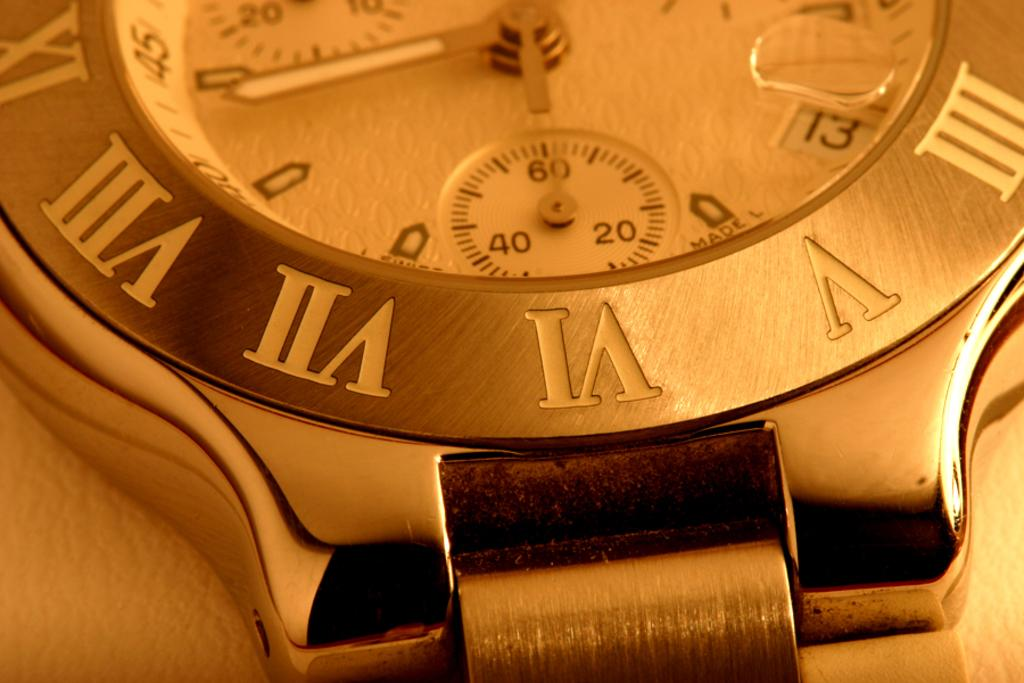Provide a one-sentence caption for the provided image. Roman numeral silver watch which contains a compass. 